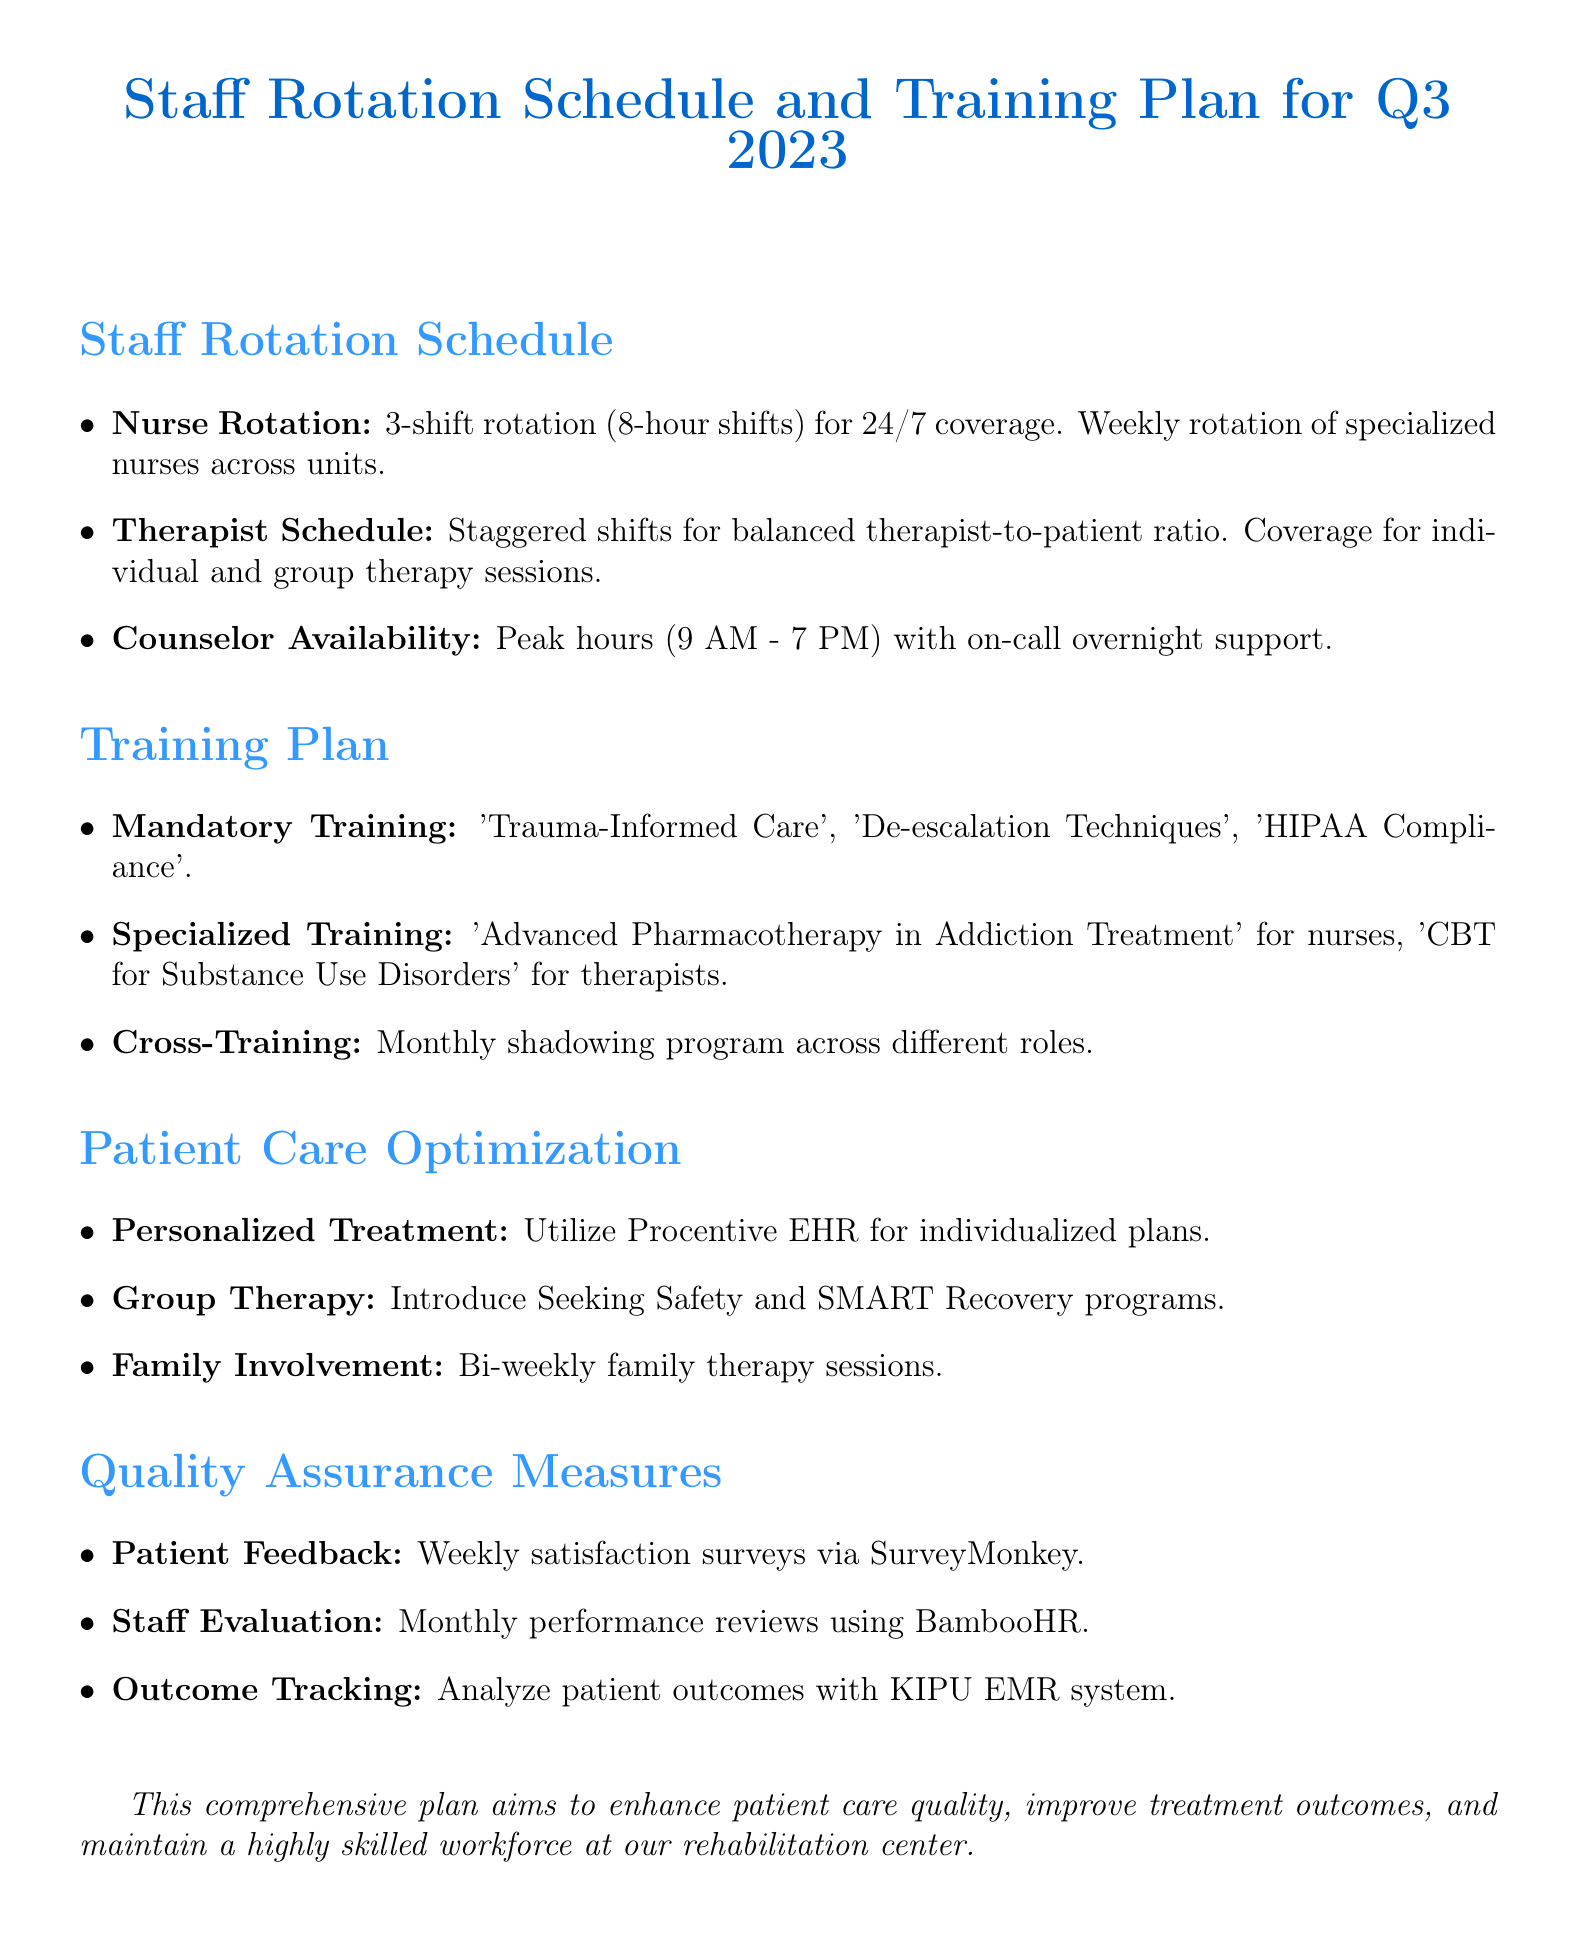What is the title of the memo? The title of the memo is stated at the beginning of the document as "Staff Rotation Schedule and Training Plan for Q3 2023."
Answer: Staff Rotation Schedule and Training Plan for Q3 2023 What is the nursing staff rotation system? The document specifies that there is a "3-shift rotation (8-hour shifts) for nursing staff to ensure 24/7 coverage."
Answer: 3-shift rotation (8-hour shifts) What training module is mandatory for all staff? The memo lists "Trauma-Informed Care" as one of the mandatory training modules for all staff members.
Answer: Trauma-Informed Care What specialized training is required for nurses? The document mentions that nurses are required to attend the "Advanced Pharmacotherapy in Addiction Treatment" workshop.
Answer: Advanced Pharmacotherapy in Addiction Treatment What time frame covers the peak hours for counselor availability? The peak hours for counselor availability are specified as "9 AM - 7 PM."
Answer: 9 AM - 7 PM What method will be used for patient feedback collection? The document indicates that a "weekly patient satisfaction survey using SurveyMonkey" will be implemented for feedback collection.
Answer: SurveyMonkey How often will staff performance evaluations occur? The memo states that "monthly performance reviews using the BambooHR system" will be conducted for staff performance evaluations.
Answer: Monthly What is the goal of the cross-training initiative? The document states that the cross-training initiative aims to "enhance understanding of the overall treatment process."
Answer: Enhance understanding of the overall treatment process What new group therapy programs are introduced? The memo mentions introducing "Seeking Safety for trauma and substance abuse, and SMART Recovery for addiction management" as new group therapy programs.
Answer: Seeking Safety and SMART Recovery What is the purpose of using the KIPU EMR system? The KIPU EMR system is used to "track and analyze patient outcomes, including relapse rates, treatment completion rates, and post-discharge follow-ups."
Answer: Track and analyze patient outcomes 